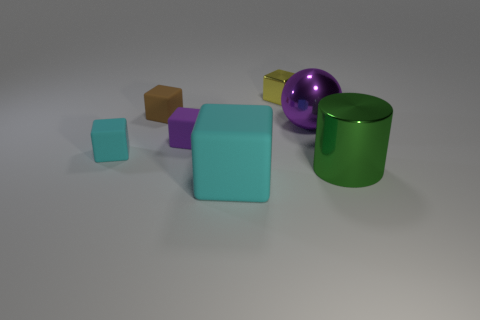There is a cyan block that is in front of the cyan rubber thing that is to the left of the object that is in front of the large green metal cylinder; what is its material?
Ensure brevity in your answer.  Rubber. Is the number of large purple objects behind the small brown cube greater than the number of tiny metallic cubes that are in front of the yellow shiny object?
Offer a terse response. No. Is the size of the purple metal sphere the same as the purple rubber object?
Provide a succinct answer. No. There is a large matte object that is the same shape as the tiny yellow thing; what is its color?
Ensure brevity in your answer.  Cyan. How many other big rubber spheres have the same color as the big sphere?
Offer a very short reply. 0. Is the number of big objects that are behind the big rubber thing greater than the number of small metal objects?
Your response must be concise. Yes. The small matte thing that is behind the large thing behind the small purple matte object is what color?
Ensure brevity in your answer.  Brown. What number of things are purple things that are on the left side of the small yellow metallic thing or small rubber things in front of the purple matte block?
Keep it short and to the point. 2. The metal cylinder has what color?
Offer a very short reply. Green. What number of tiny purple objects have the same material as the big cyan object?
Provide a short and direct response. 1. 